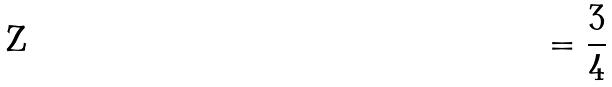<formula> <loc_0><loc_0><loc_500><loc_500>= \frac { 3 } { 4 }</formula> 